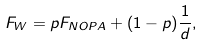Convert formula to latex. <formula><loc_0><loc_0><loc_500><loc_500>F _ { W } = p F _ { N O P A } + ( 1 - p ) \frac { 1 } { d } ,</formula> 